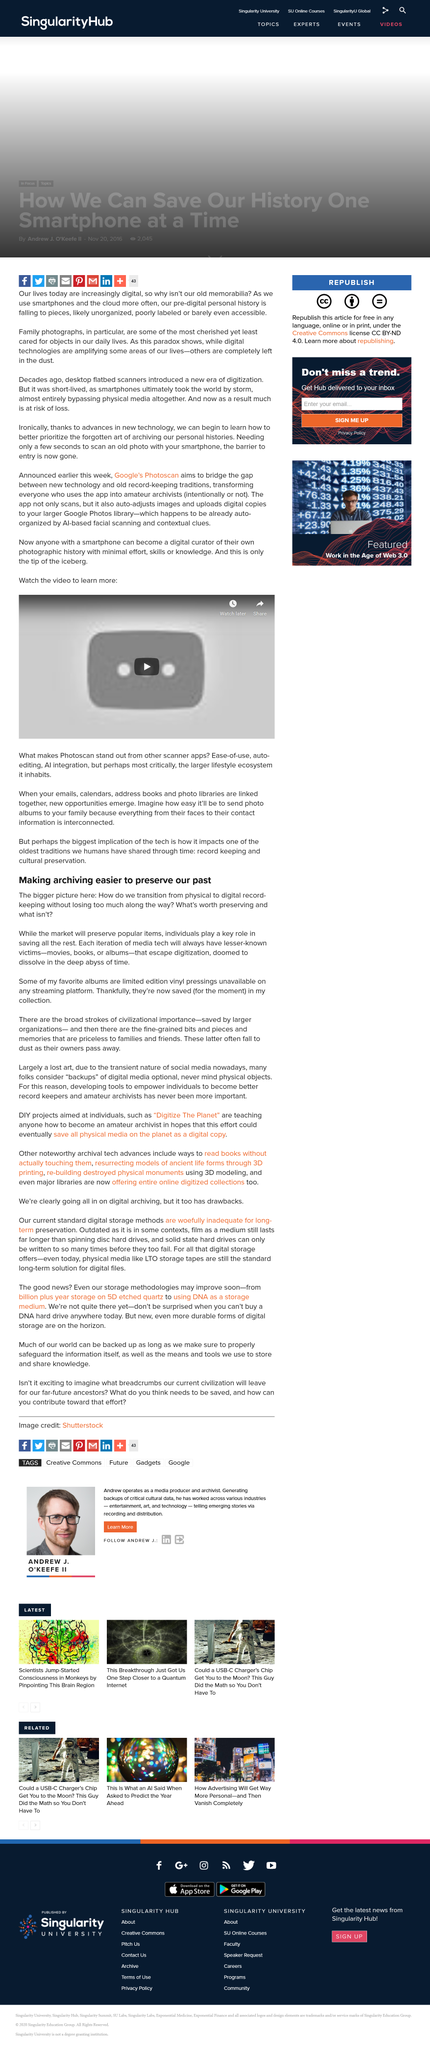Indicate a few pertinent items in this graphic. The subtitle is called 'Making archiving easier to preserve our past,' which aims to achieve the goal of preserving our past. The victims will be consumed by the depths of time and dissolve into oblivion, leaving behind movies, books, and albums as the only remnants of their existence. Some people have problems with their favorite albums because they are limited edition. 